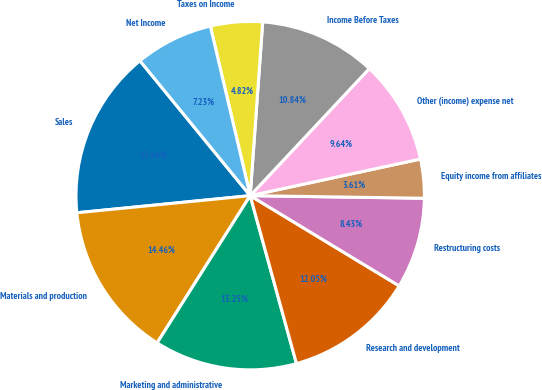Convert chart to OTSL. <chart><loc_0><loc_0><loc_500><loc_500><pie_chart><fcel>Sales<fcel>Materials and production<fcel>Marketing and administrative<fcel>Research and development<fcel>Restructuring costs<fcel>Equity income from affiliates<fcel>Other (income) expense net<fcel>Income Before Taxes<fcel>Taxes on Income<fcel>Net Income<nl><fcel>15.66%<fcel>14.46%<fcel>13.25%<fcel>12.05%<fcel>8.43%<fcel>3.61%<fcel>9.64%<fcel>10.84%<fcel>4.82%<fcel>7.23%<nl></chart> 